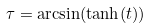Convert formula to latex. <formula><loc_0><loc_0><loc_500><loc_500>\tau = \arcsin ( \tanh ( t ) )</formula> 